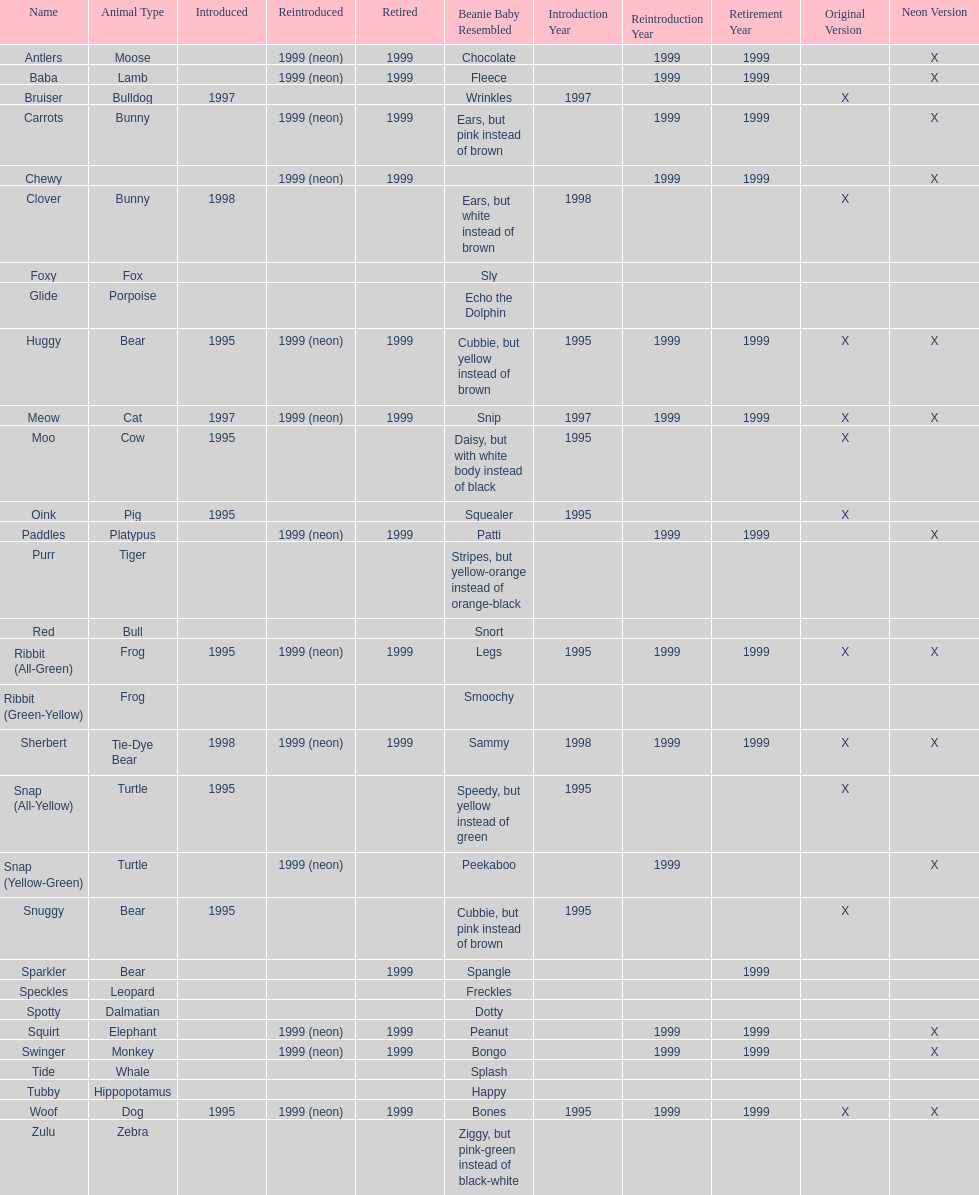In what year were the first pillow pals introduced? 1995. Would you mind parsing the complete table? {'header': ['Name', 'Animal Type', 'Introduced', 'Reintroduced', 'Retired', 'Beanie Baby Resembled', 'Introduction Year', 'Reintroduction Year', 'Retirement Year', 'Original Version', 'Neon Version'], 'rows': [['Antlers', 'Moose', '', '1999 (neon)', '1999', 'Chocolate', '', '1999', '1999', '', 'X'], ['Baba', 'Lamb', '', '1999 (neon)', '1999', 'Fleece', '', '1999', '1999', '', 'X'], ['Bruiser', 'Bulldog', '1997', '', '', 'Wrinkles', '1997', '', '', 'X', ''], ['Carrots', 'Bunny', '', '1999 (neon)', '1999', 'Ears, but pink instead of brown', '', '1999', '1999', '', 'X'], ['Chewy', '', '', '1999 (neon)', '1999', '', '', '1999', '1999', '', 'X'], ['Clover', 'Bunny', '1998', '', '', 'Ears, but white instead of brown', '1998', '', '', 'X', ''], ['Foxy', 'Fox', '', '', '', 'Sly', '', '', '', '', ''], ['Glide', 'Porpoise', '', '', '', 'Echo the Dolphin', '', '', '', '', ''], ['Huggy', 'Bear', '1995', '1999 (neon)', '1999', 'Cubbie, but yellow instead of brown', '1995', '1999', '1999', 'X', 'X'], ['Meow', 'Cat', '1997', '1999 (neon)', '1999', 'Snip', '1997', '1999', '1999', 'X', 'X'], ['Moo', 'Cow', '1995', '', '', 'Daisy, but with white body instead of black', '1995', '', '', 'X', ''], ['Oink', 'Pig', '1995', '', '', 'Squealer', '1995', '', '', 'X', ''], ['Paddles', 'Platypus', '', '1999 (neon)', '1999', 'Patti', '', '1999', '1999', '', 'X'], ['Purr', 'Tiger', '', '', '', 'Stripes, but yellow-orange instead of orange-black', '', '', '', '', ''], ['Red', 'Bull', '', '', '', 'Snort', '', '', '', '', ''], ['Ribbit (All-Green)', 'Frog', '1995', '1999 (neon)', '1999', 'Legs', '1995', '1999', '1999', 'X', 'X'], ['Ribbit (Green-Yellow)', 'Frog', '', '', '', 'Smoochy', '', '', '', '', ''], ['Sherbert', 'Tie-Dye Bear', '1998', '1999 (neon)', '1999', 'Sammy', '1998', '1999', '1999', 'X', 'X'], ['Snap (All-Yellow)', 'Turtle', '1995', '', '', 'Speedy, but yellow instead of green', '1995', '', '', 'X', ''], ['Snap (Yellow-Green)', 'Turtle', '', '1999 (neon)', '', 'Peekaboo', '', '1999', '', '', 'X'], ['Snuggy', 'Bear', '1995', '', '', 'Cubbie, but pink instead of brown', '1995', '', '', 'X', ''], ['Sparkler', 'Bear', '', '', '1999', 'Spangle', '', '', '1999', '', ''], ['Speckles', 'Leopard', '', '', '', 'Freckles', '', '', '', '', ''], ['Spotty', 'Dalmatian', '', '', '', 'Dotty', '', '', '', '', ''], ['Squirt', 'Elephant', '', '1999 (neon)', '1999', 'Peanut', '', '1999', '1999', '', 'X'], ['Swinger', 'Monkey', '', '1999 (neon)', '1999', 'Bongo', '', '1999', '1999', '', 'X'], ['Tide', 'Whale', '', '', '', 'Splash', '', '', '', '', ''], ['Tubby', 'Hippopotamus', '', '', '', 'Happy', '', '', '', '', ''], ['Woof', 'Dog', '1995', '1999 (neon)', '1999', 'Bones', '1995', '1999', '1999', 'X', 'X'], ['Zulu', 'Zebra', '', '', '', 'Ziggy, but pink-green instead of black-white', '', '', '', '', '']]} 